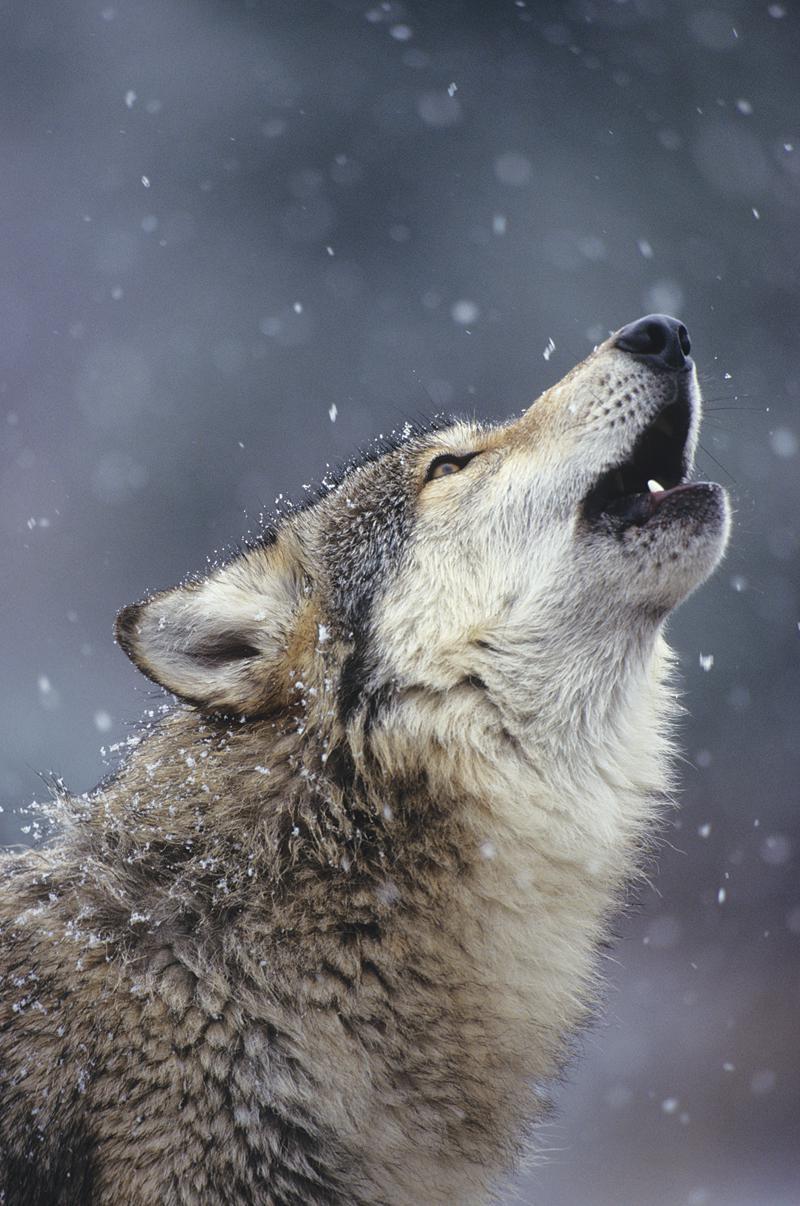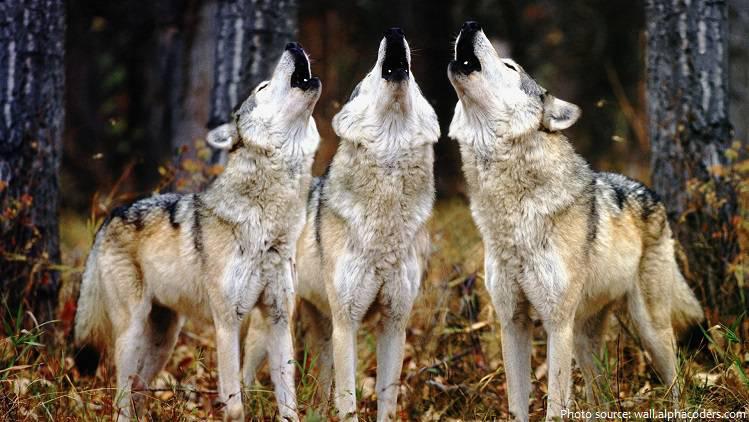The first image is the image on the left, the second image is the image on the right. Given the left and right images, does the statement "There are exactly two wolves howling in the snow." hold true? Answer yes or no. No. The first image is the image on the left, the second image is the image on the right. Analyze the images presented: Is the assertion "There are only two dogs and both are howling at the sky." valid? Answer yes or no. No. 